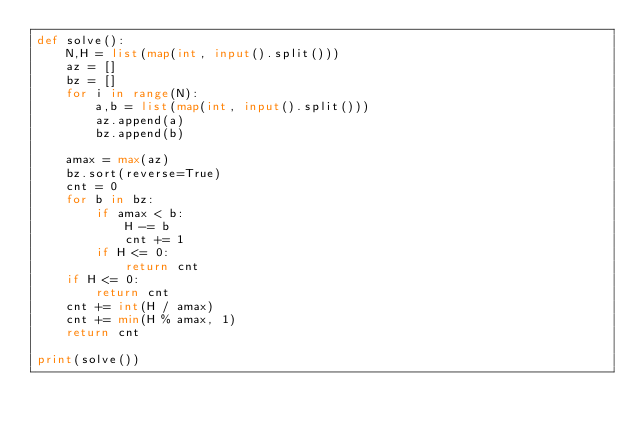<code> <loc_0><loc_0><loc_500><loc_500><_Python_>def solve():
    N,H = list(map(int, input().split()))
    az = []
    bz = []
    for i in range(N):
        a,b = list(map(int, input().split()))
        az.append(a)
        bz.append(b)
        
    amax = max(az)
    bz.sort(reverse=True)
    cnt = 0
    for b in bz:
        if amax < b:
            H -= b
            cnt += 1
        if H <= 0:
            return cnt
    if H <= 0:
        return cnt
    cnt += int(H / amax)
    cnt += min(H % amax, 1)
    return cnt
        
print(solve())</code> 